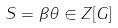<formula> <loc_0><loc_0><loc_500><loc_500>S = \beta \theta \in Z [ G ]</formula> 